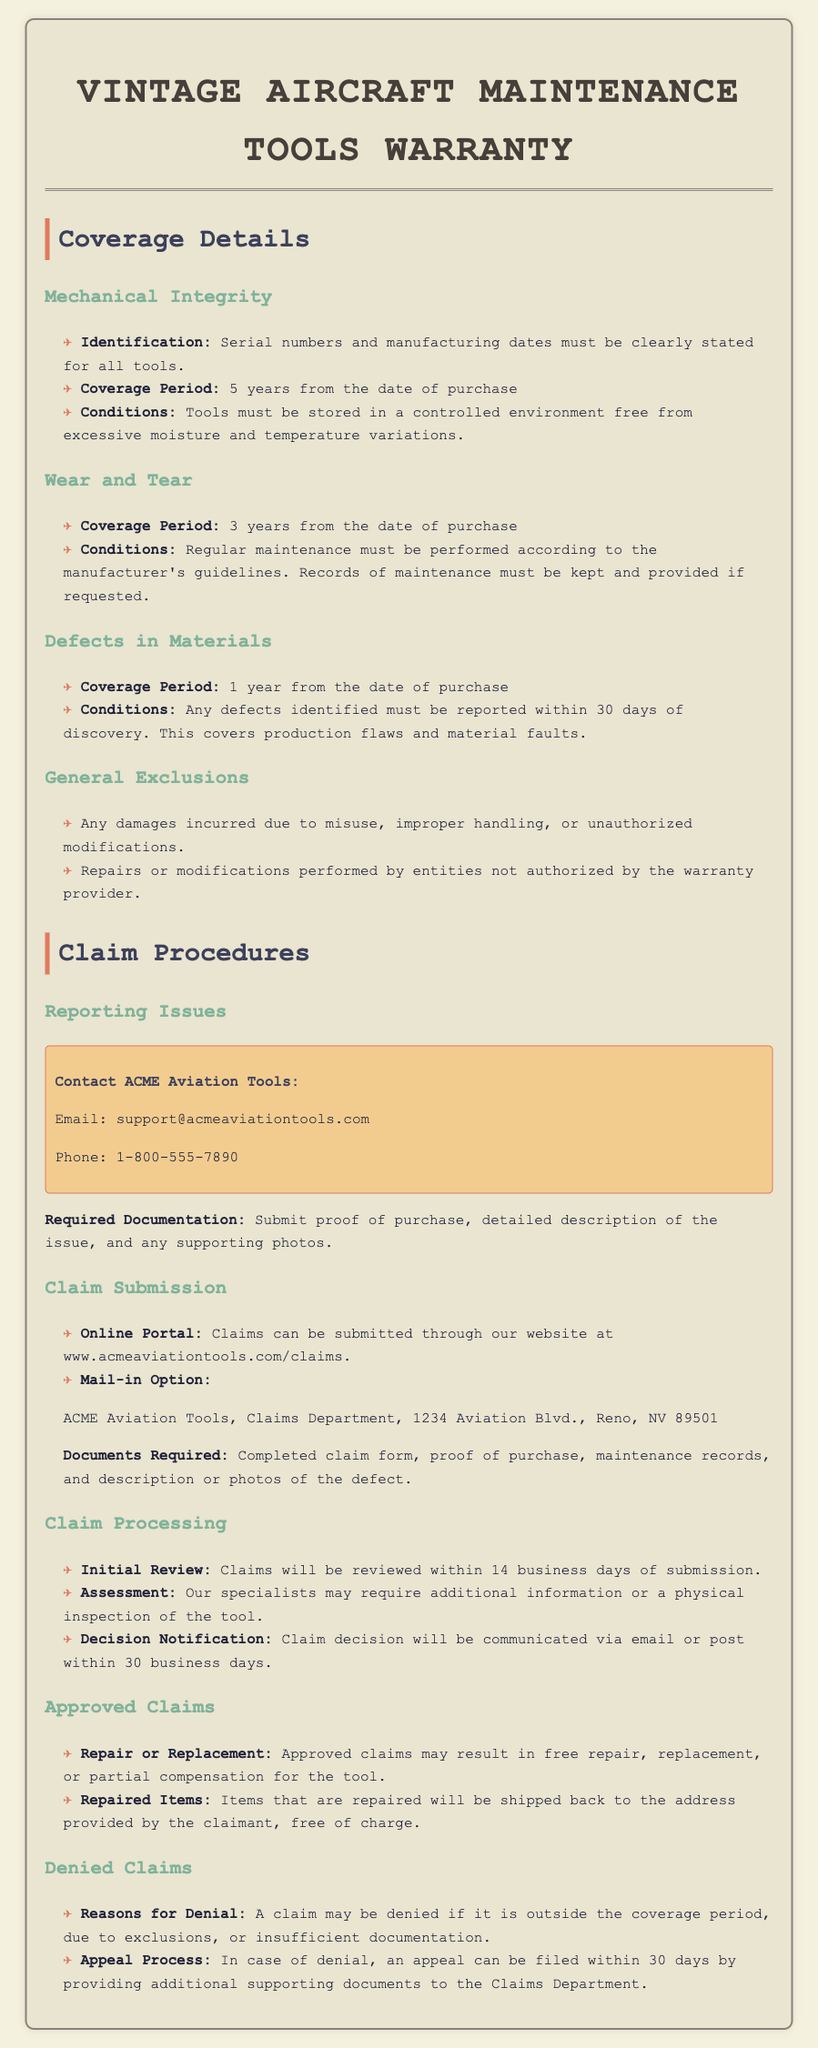What is the coverage period for mechanical integrity? The coverage period for mechanical integrity is specified in the document as a duration from the date of purchase.
Answer: 5 years What must be kept and provided for wear and tear coverage? The document states that regular maintenance must be performed and records kept.
Answer: Maintenance records What is the contact email for submitting claims? This is a specific detail provided for reporting issues in the document.
Answer: support@acmeaviationtools.com What happens to approved claims? This question requires understanding the outcome detailed in the claims procedures section.
Answer: Repair, replacement, or partial compensation What is the timeframe for initial claim review? The document mentions the duration for reviewing claims, which is crucial for understanding processing times.
Answer: 14 business days What should be included with the mail-in claim submission? This question addresses the specific documentation needed when claims are mailed in.
Answer: Completed claim form, proof of purchase, maintenance records What is the appeal period for denied claims? This question is about the timeframe allowed for appealing a denied claim.
Answer: 30 days What type of damages are excluded from coverage? The document lists specific exclusions regarding the warranty coverage for tools.
Answer: Misuse, improper handling, unauthorized modifications 